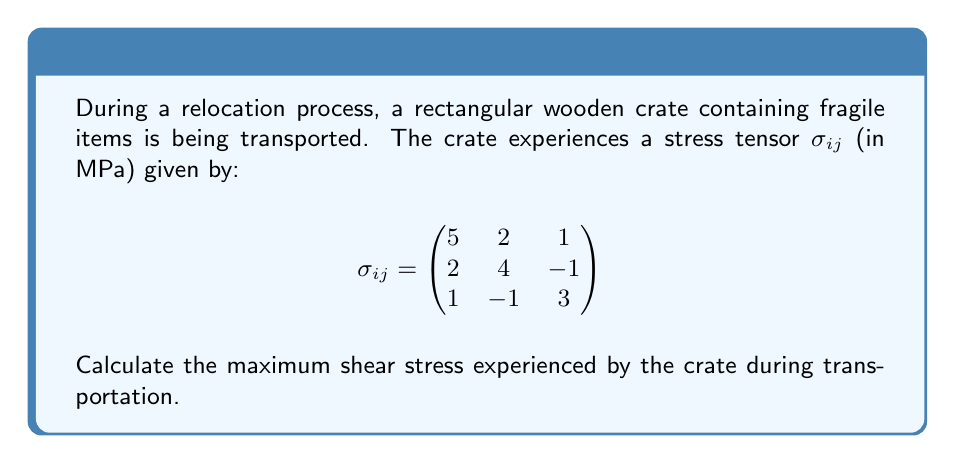Give your solution to this math problem. To find the maximum shear stress, we need to follow these steps:

1) First, we need to calculate the principal stresses. These are the eigenvalues of the stress tensor.

2) The characteristic equation for the eigenvalues is:
   $$\det(\sigma_{ij} - \lambda I) = 0$$

3) Expanding this determinant:
   $$\begin{vmatrix}
   5-\lambda & 2 & 1 \\
   2 & 4-\lambda & -1 \\
   1 & -1 & 3-\lambda
   \end{vmatrix} = 0$$

4) This gives us the cubic equation:
   $$-\lambda^3 + 12\lambda^2 - 41\lambda + 38 = 0$$

5) Solving this equation (using a calculator or computer algebra system) gives us the eigenvalues:
   $$\lambda_1 \approx 7.5396, \lambda_2 \approx 2.5396, \lambda_3 \approx 1.9208$$

6) The maximum shear stress $\tau_{max}$ is given by half the difference between the largest and smallest principal stresses:

   $$\tau_{max} = \frac{1}{2}(\lambda_{max} - \lambda_{min}) = \frac{1}{2}(7.5396 - 1.9208) \approx 2.8094$$

Therefore, the maximum shear stress experienced by the crate is approximately 2.8094 MPa.
Answer: $\tau_{max} \approx 2.8094$ MPa 